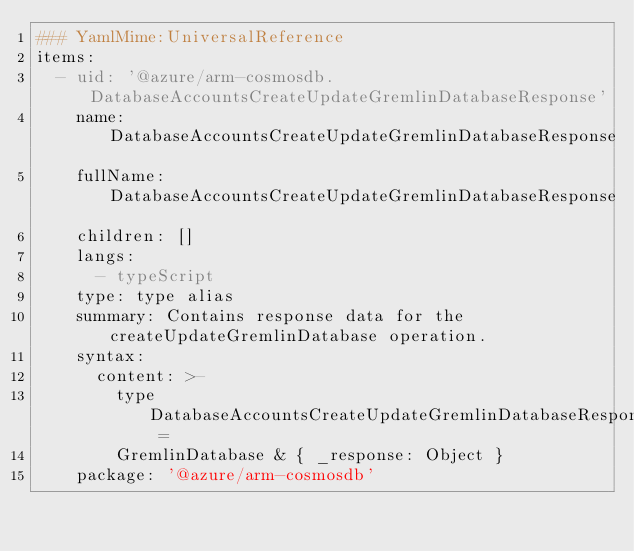Convert code to text. <code><loc_0><loc_0><loc_500><loc_500><_YAML_>### YamlMime:UniversalReference
items:
  - uid: '@azure/arm-cosmosdb.DatabaseAccountsCreateUpdateGremlinDatabaseResponse'
    name: DatabaseAccountsCreateUpdateGremlinDatabaseResponse
    fullName: DatabaseAccountsCreateUpdateGremlinDatabaseResponse
    children: []
    langs:
      - typeScript
    type: type alias
    summary: Contains response data for the createUpdateGremlinDatabase operation.
    syntax:
      content: >-
        type DatabaseAccountsCreateUpdateGremlinDatabaseResponse =
        GremlinDatabase & { _response: Object }
    package: '@azure/arm-cosmosdb'
</code> 